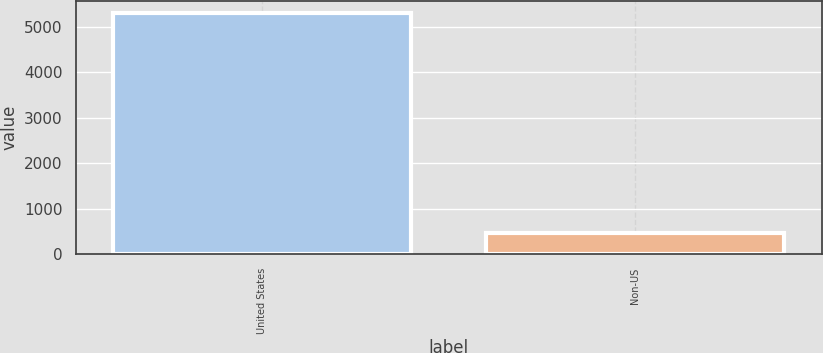Convert chart. <chart><loc_0><loc_0><loc_500><loc_500><bar_chart><fcel>United States<fcel>Non-US<nl><fcel>5309<fcel>467<nl></chart> 